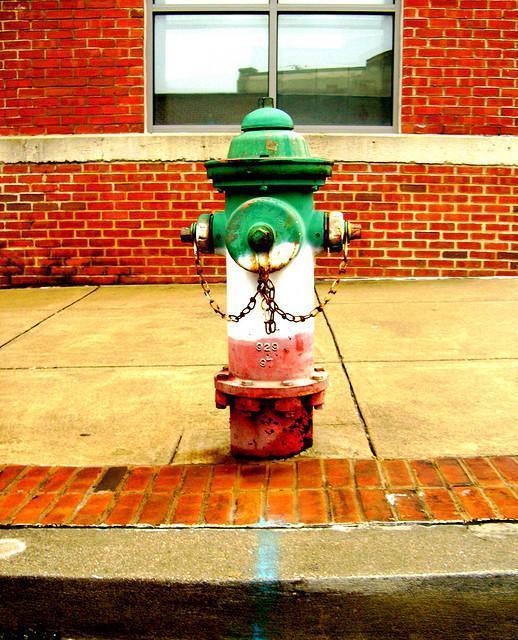How many different colors are on the hydrant?
Give a very brief answer. 3. 